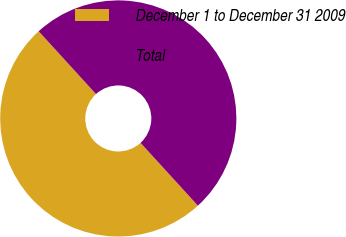<chart> <loc_0><loc_0><loc_500><loc_500><pie_chart><fcel>December 1 to December 31 2009<fcel>Total<nl><fcel>50.0%<fcel>50.0%<nl></chart> 